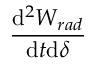<formula> <loc_0><loc_0><loc_500><loc_500>\frac { d ^ { 2 } W _ { r a d } } { d t d \delta }</formula> 